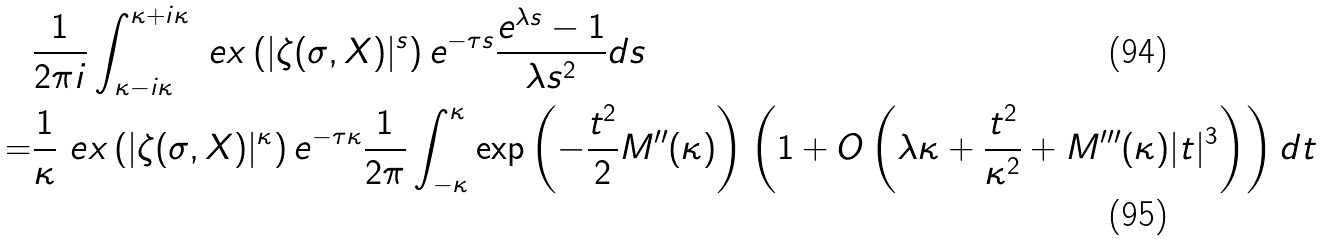<formula> <loc_0><loc_0><loc_500><loc_500>& \frac { 1 } { 2 \pi i } \int _ { \kappa - i \kappa } ^ { \kappa + i \kappa } \ e x \left ( | \zeta ( \sigma , X ) | ^ { s } \right ) e ^ { - \tau s } \frac { e ^ { \lambda s } - 1 } { \lambda s ^ { 2 } } d s \\ = & \frac { 1 } { \kappa } \ e x \left ( | \zeta ( \sigma , X ) | ^ { \kappa } \right ) e ^ { - \tau \kappa } \frac { 1 } { 2 \pi } \int _ { - \kappa } ^ { \kappa } \exp \left ( - \frac { t ^ { 2 } } { 2 } M ^ { \prime \prime } ( \kappa ) \right ) \left ( 1 + O \left ( \lambda \kappa + \frac { t ^ { 2 } } { \kappa ^ { 2 } } + M ^ { \prime \prime \prime } ( \kappa ) | t | ^ { 3 } \right ) \right ) d t</formula> 